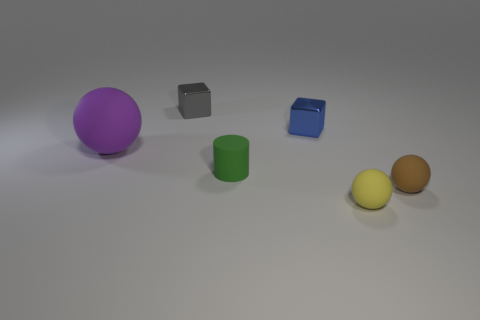Subtract all tiny spheres. How many spheres are left? 1 Add 3 blue shiny things. How many objects exist? 9 Subtract all cylinders. How many objects are left? 5 Subtract all big balls. Subtract all big yellow metallic cylinders. How many objects are left? 5 Add 4 green rubber cylinders. How many green rubber cylinders are left? 5 Add 4 large cyan shiny objects. How many large cyan shiny objects exist? 4 Subtract 0 purple blocks. How many objects are left? 6 